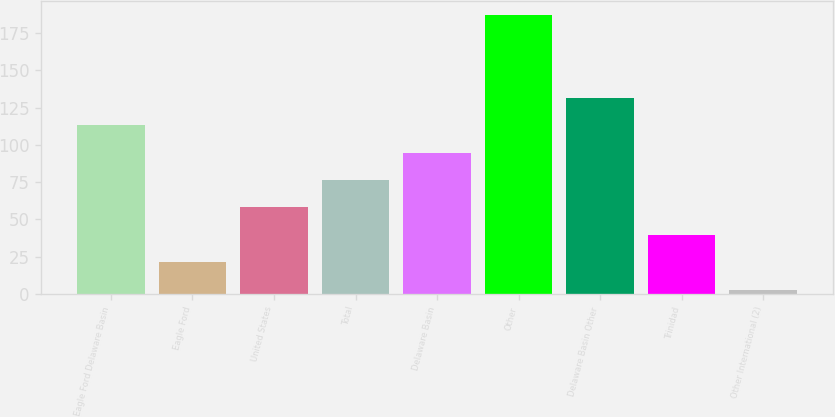<chart> <loc_0><loc_0><loc_500><loc_500><bar_chart><fcel>Eagle Ford Delaware Basin<fcel>Eagle Ford<fcel>United States<fcel>Total<fcel>Delaware Basin<fcel>Other<fcel>Delaware Basin Other<fcel>Trinidad<fcel>Other International (2)<nl><fcel>113.32<fcel>21.22<fcel>58.06<fcel>76.48<fcel>94.9<fcel>187<fcel>131.74<fcel>39.64<fcel>2.8<nl></chart> 